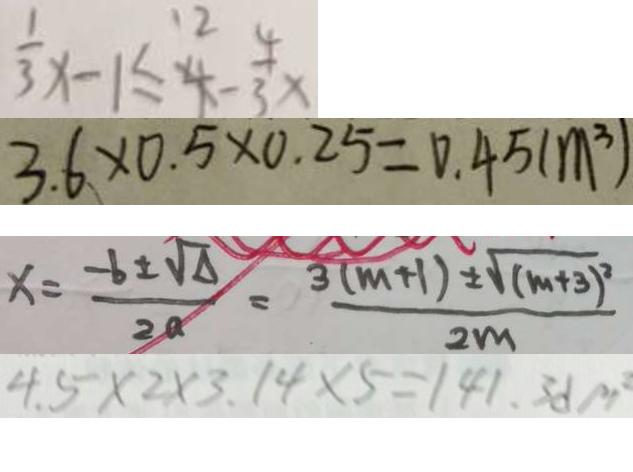Convert formula to latex. <formula><loc_0><loc_0><loc_500><loc_500>\frac { 1 } { 3 } x - 1 \leq 4 - \frac { 4 } { 3 } x 
 3 . 6 \times 0 . 5 \times 0 . 2 5 = 0 . 4 5 ( m ^ { 3 } ) 
 x = \frac { - b \pm \sqrt { \Delta } } { 2 a } = \frac { 3 ( m + 1 ) \pm \sqrt { ( m + 3 ) ^ { 2 } } } { 2 m } 
 4 . 5 \times 2 \times 3 . 1 4 \times 5 = 1 4 1 . 3 d p</formula> 